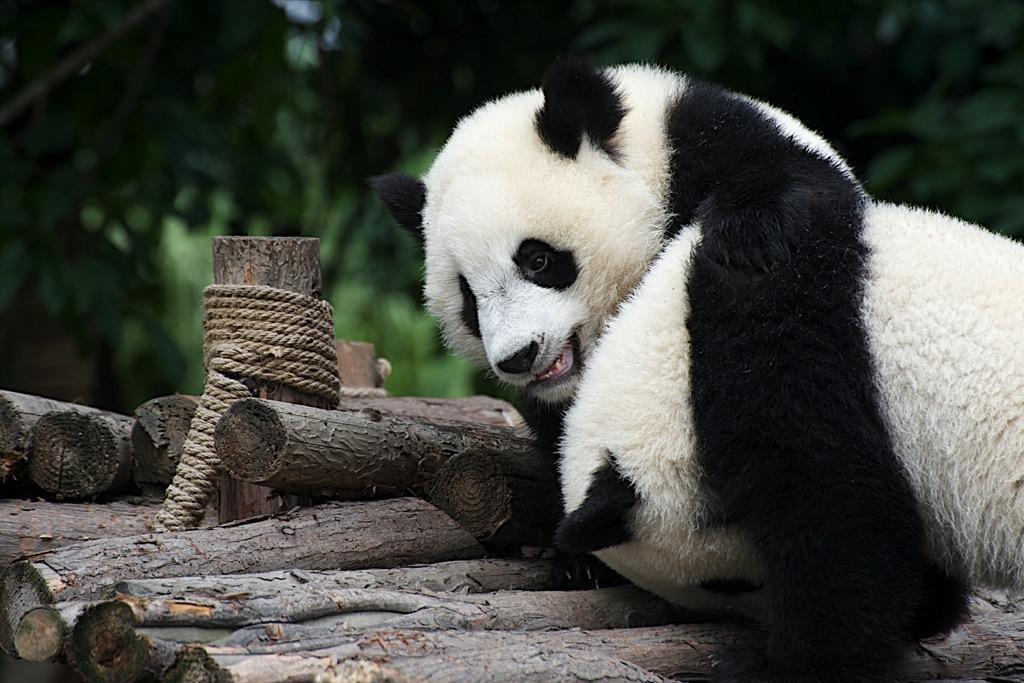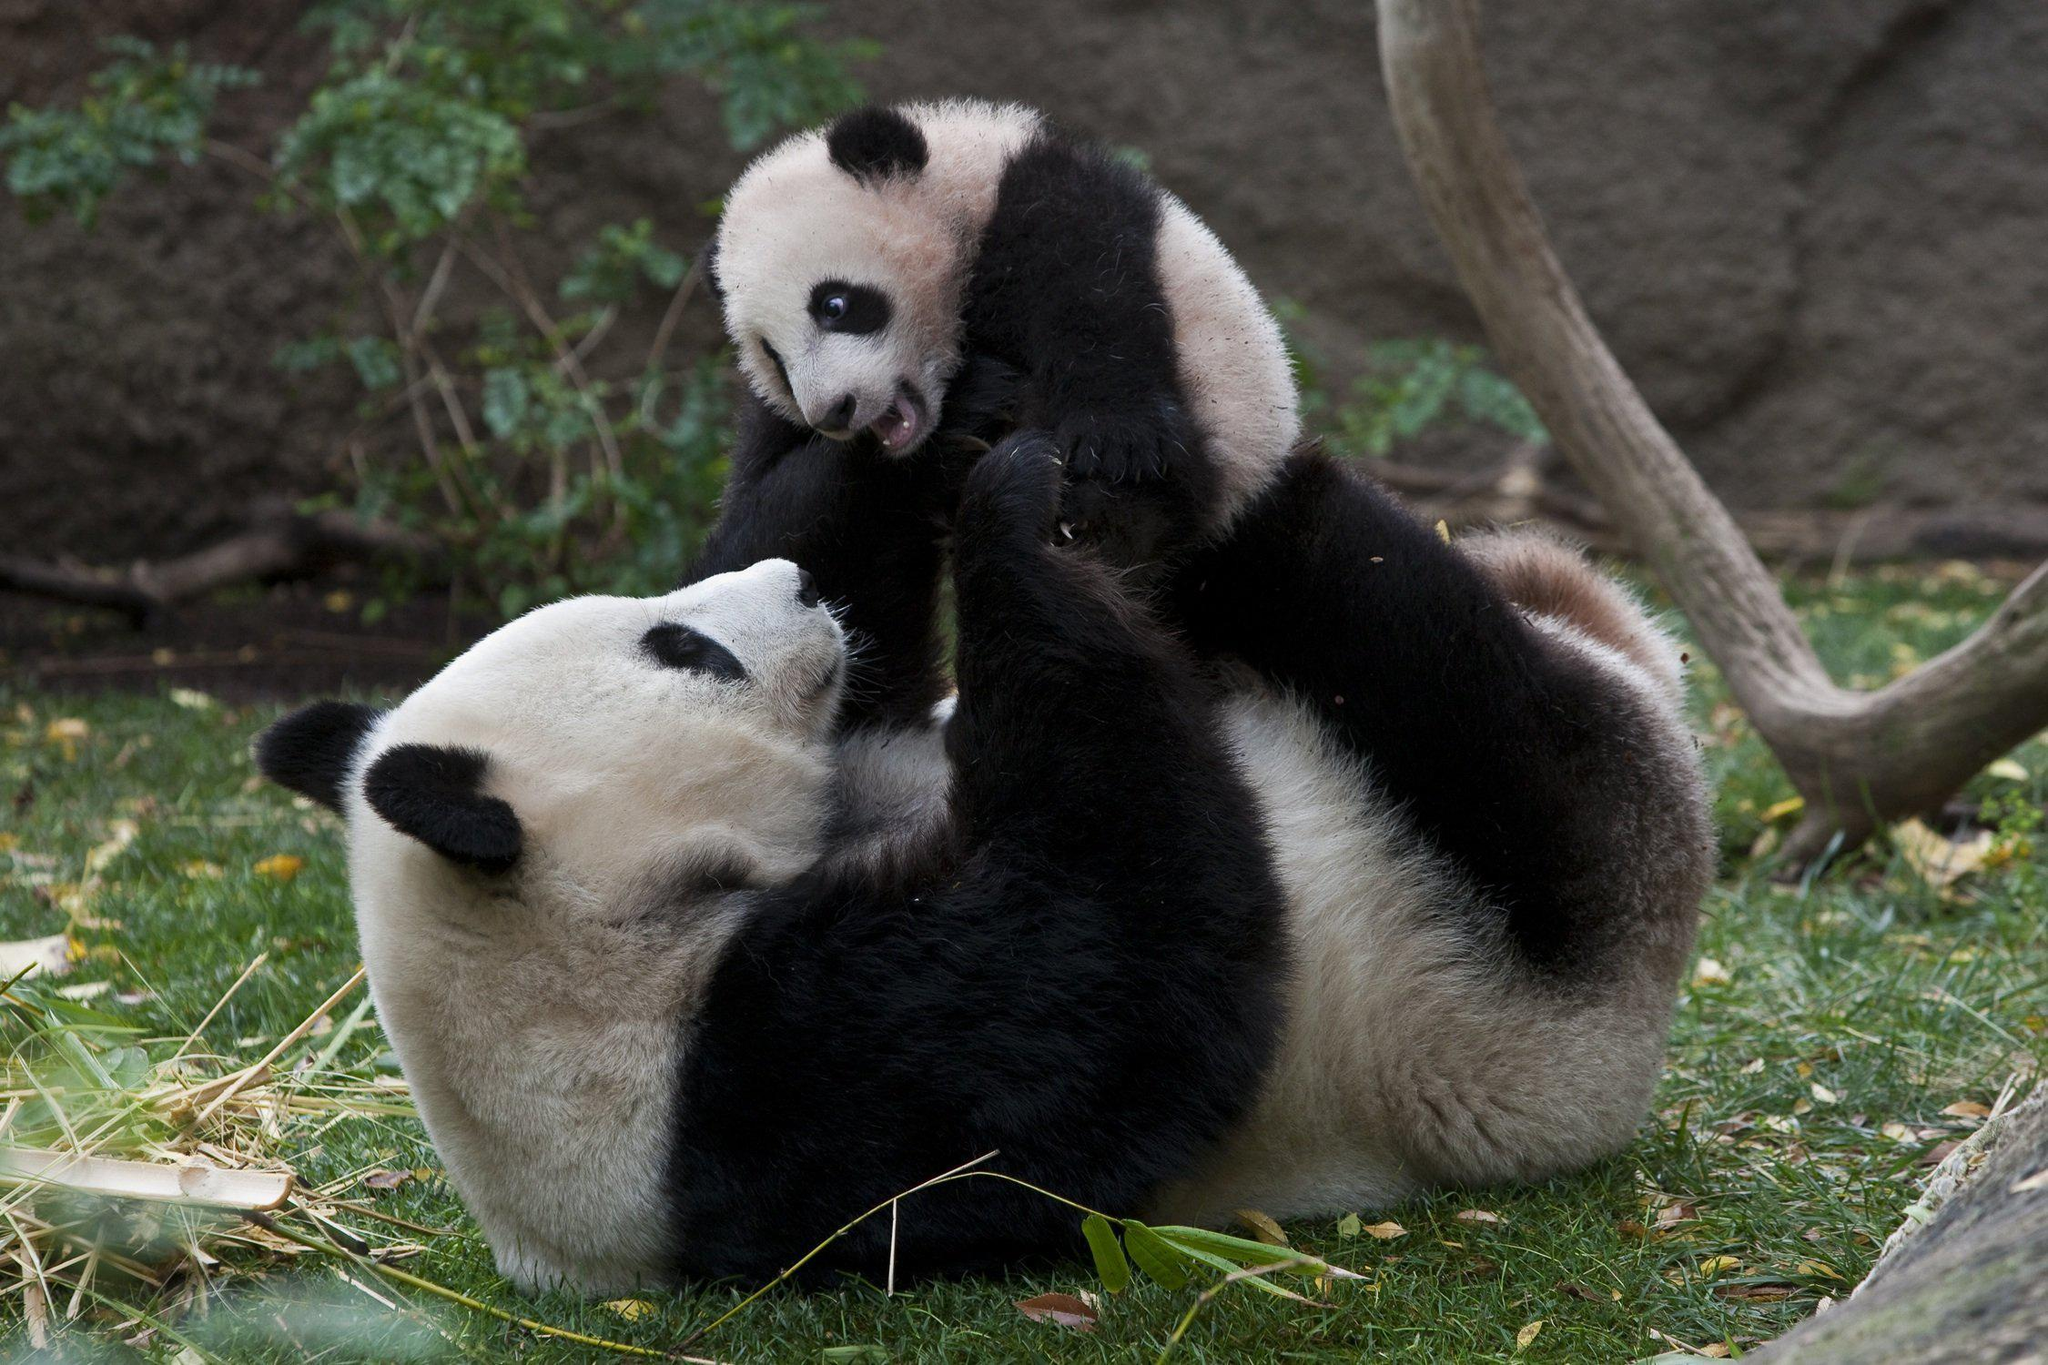The first image is the image on the left, the second image is the image on the right. Analyze the images presented: Is the assertion "The left and right image contains the same number of pandas sitting next to each other." valid? Answer yes or no. No. The first image is the image on the left, the second image is the image on the right. Analyze the images presented: Is the assertion "In one image, two pandas are sitting close together with at least one of them clutching a green stalk, and the other image shows two pandas with their bodies facing." valid? Answer yes or no. No. 